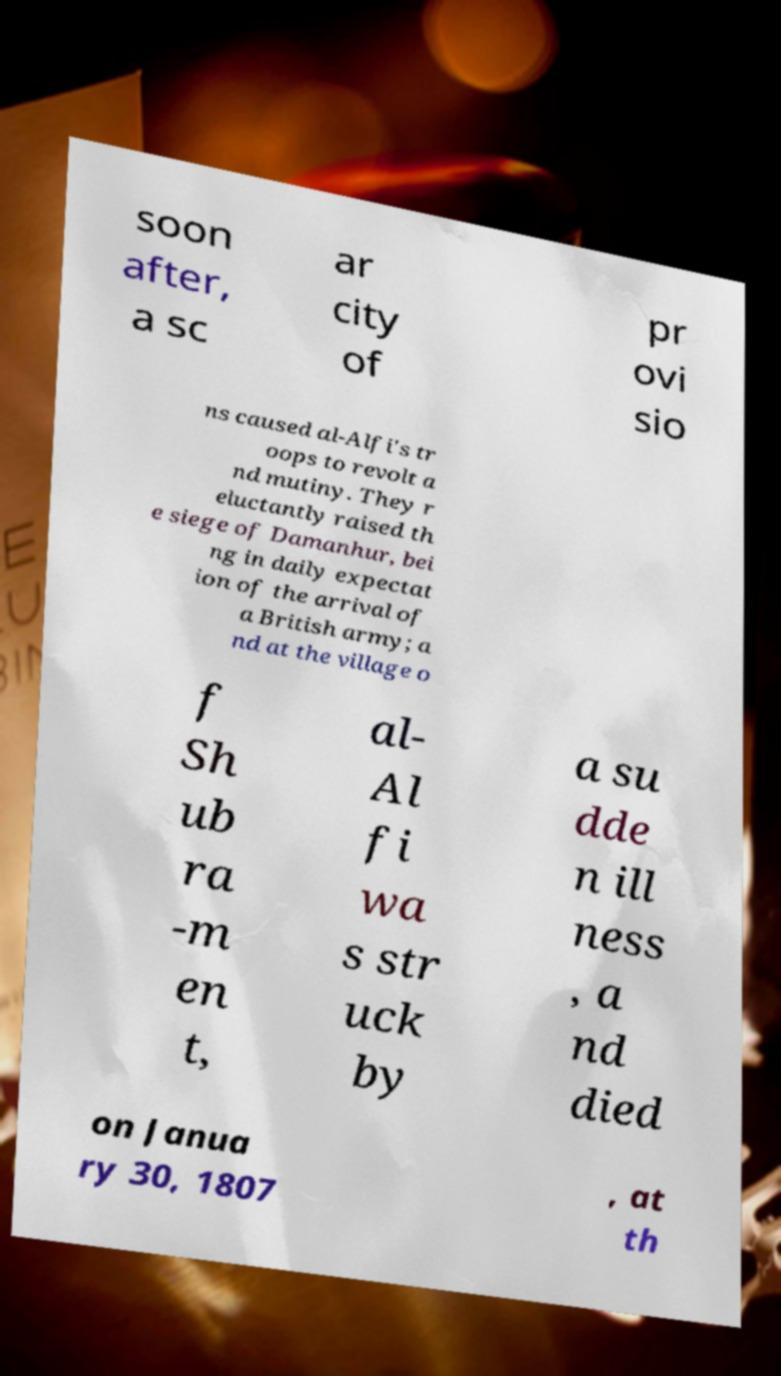Could you assist in decoding the text presented in this image and type it out clearly? soon after, a sc ar city of pr ovi sio ns caused al-Alfi's tr oops to revolt a nd mutiny. They r eluctantly raised th e siege of Damanhur, bei ng in daily expectat ion of the arrival of a British army; a nd at the village o f Sh ub ra -m en t, al- Al fi wa s str uck by a su dde n ill ness , a nd died on Janua ry 30, 1807 , at th 